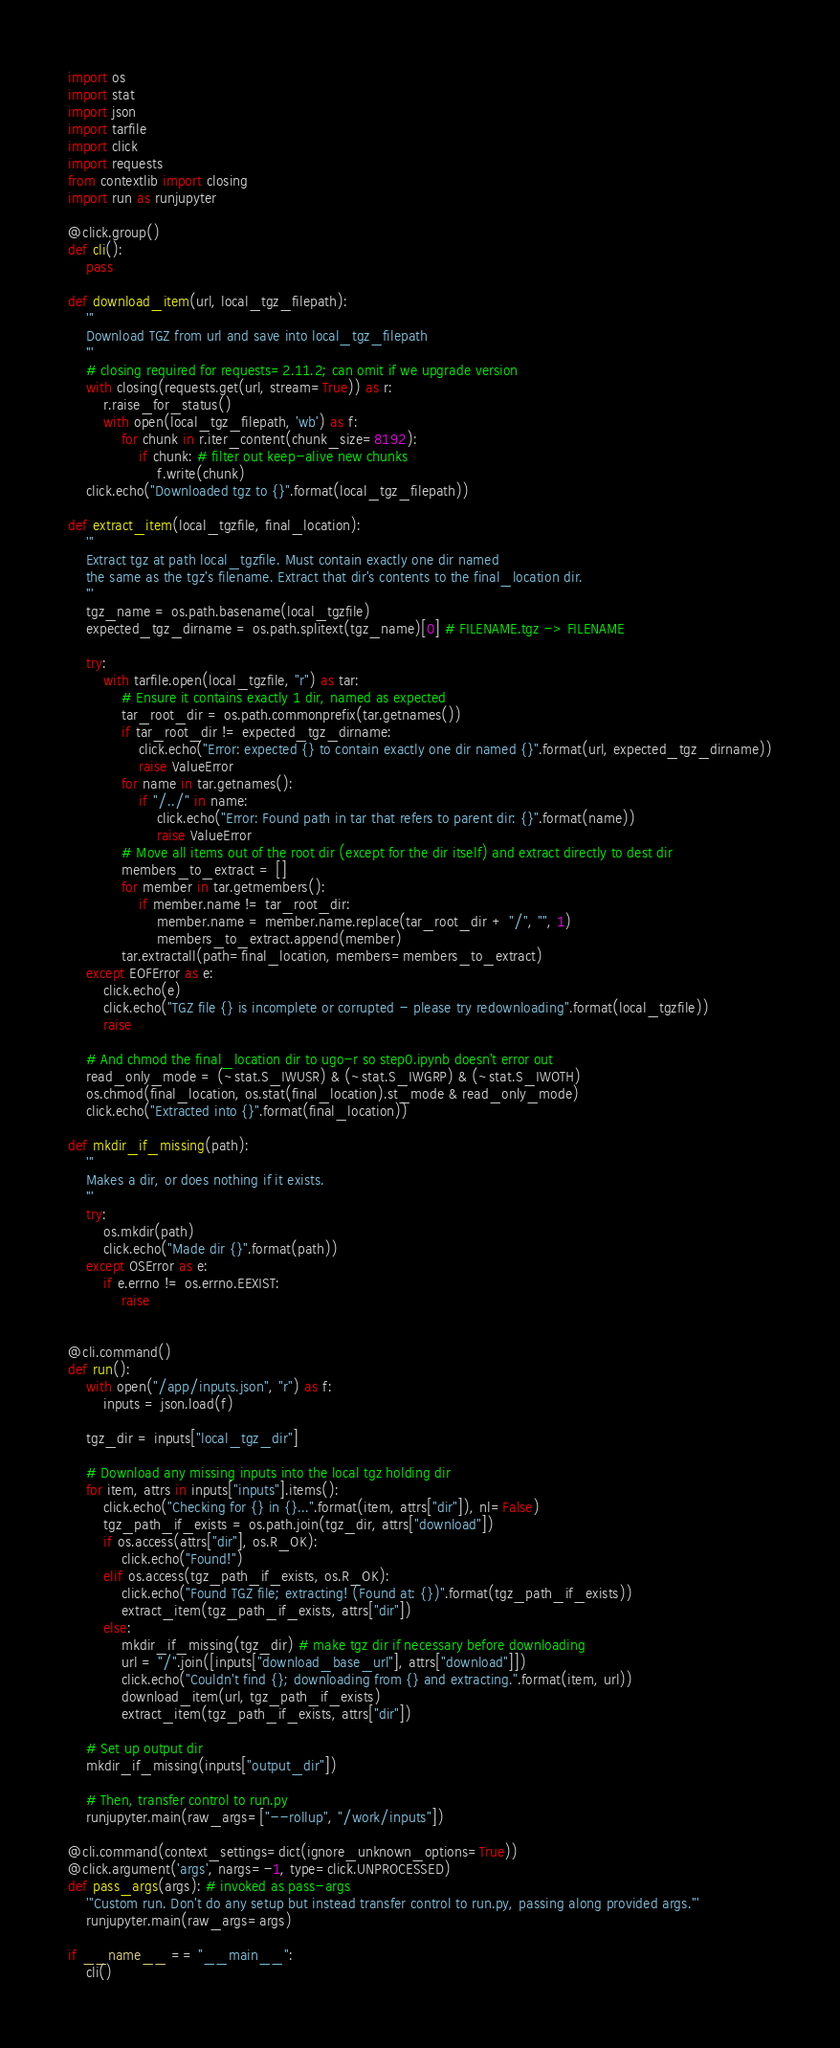<code> <loc_0><loc_0><loc_500><loc_500><_Python_>import os
import stat
import json
import tarfile
import click
import requests
from contextlib import closing
import run as runjupyter

@click.group()
def cli():
    pass

def download_item(url, local_tgz_filepath):
    '''
    Download TGZ from url and save into local_tgz_filepath
    '''
    # closing required for requests=2.11.2; can omit if we upgrade version
    with closing(requests.get(url, stream=True)) as r:
        r.raise_for_status()
        with open(local_tgz_filepath, 'wb') as f:
            for chunk in r.iter_content(chunk_size=8192): 
                if chunk: # filter out keep-alive new chunks
                    f.write(chunk)
    click.echo("Downloaded tgz to {}".format(local_tgz_filepath))

def extract_item(local_tgzfile, final_location):
    '''
    Extract tgz at path local_tgzfile. Must contain exactly one dir named
    the same as the tgz's filename. Extract that dir's contents to the final_location dir.
    '''
    tgz_name = os.path.basename(local_tgzfile)
    expected_tgz_dirname = os.path.splitext(tgz_name)[0] # FILENAME.tgz -> FILENAME

    try:
        with tarfile.open(local_tgzfile, "r") as tar:
            # Ensure it contains exactly 1 dir, named as expected
            tar_root_dir = os.path.commonprefix(tar.getnames())
            if tar_root_dir != expected_tgz_dirname:
                click.echo("Error: expected {} to contain exactly one dir named {}".format(url, expected_tgz_dirname))
                raise ValueError
            for name in tar.getnames():
                if "/../" in name:
                    click.echo("Error: Found path in tar that refers to parent dir: {}".format(name))
                    raise ValueError
            # Move all items out of the root dir (except for the dir itself) and extract directly to dest dir
            members_to_extract = []
            for member in tar.getmembers():
                if member.name != tar_root_dir:
                    member.name = member.name.replace(tar_root_dir + "/", "", 1)
                    members_to_extract.append(member)
            tar.extractall(path=final_location, members=members_to_extract)
    except EOFError as e:
        click.echo(e)
        click.echo("TGZ file {} is incomplete or corrupted - please try redownloading".format(local_tgzfile))
        raise

    # And chmod the final_location dir to ugo-r so step0.ipynb doesn't error out
    read_only_mode = (~stat.S_IWUSR) & (~stat.S_IWGRP) & (~stat.S_IWOTH)
    os.chmod(final_location, os.stat(final_location).st_mode & read_only_mode)
    click.echo("Extracted into {}".format(final_location))

def mkdir_if_missing(path):
    '''
    Makes a dir, or does nothing if it exists.
    '''
    try:
        os.mkdir(path)
        click.echo("Made dir {}".format(path))
    except OSError as e:
        if e.errno != os.errno.EEXIST:
            raise


@cli.command()
def run():
    with open("/app/inputs.json", "r") as f: 
        inputs = json.load(f)

    tgz_dir = inputs["local_tgz_dir"]

    # Download any missing inputs into the local tgz holding dir
    for item, attrs in inputs["inputs"].items():
        click.echo("Checking for {} in {}...".format(item, attrs["dir"]), nl=False)
        tgz_path_if_exists = os.path.join(tgz_dir, attrs["download"])
        if os.access(attrs["dir"], os.R_OK):
            click.echo("Found!")
        elif os.access(tgz_path_if_exists, os.R_OK):
            click.echo("Found TGZ file; extracting! (Found at: {})".format(tgz_path_if_exists))
            extract_item(tgz_path_if_exists, attrs["dir"])
        else:
            mkdir_if_missing(tgz_dir) # make tgz dir if necessary before downloading
            url = "/".join([inputs["download_base_url"], attrs["download"]])
            click.echo("Couldn't find {}; downloading from {} and extracting.".format(item, url))
            download_item(url, tgz_path_if_exists)
            extract_item(tgz_path_if_exists, attrs["dir"])

    # Set up output dir
    mkdir_if_missing(inputs["output_dir"])

    # Then, transfer control to run.py
    runjupyter.main(raw_args=["--rollup", "/work/inputs"])

@cli.command(context_settings=dict(ignore_unknown_options=True))
@click.argument('args', nargs=-1, type=click.UNPROCESSED)
def pass_args(args): # invoked as pass-args
    '''Custom run. Don't do any setup but instead transfer control to run.py, passing along provided args.'''
    runjupyter.main(raw_args=args)

if __name__ == "__main__":
    cli()
</code> 